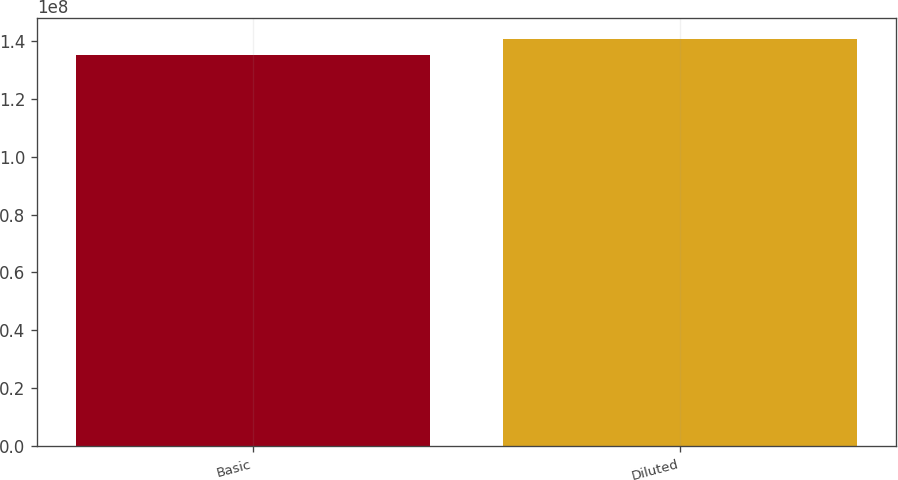<chart> <loc_0><loc_0><loc_500><loc_500><bar_chart><fcel>Basic<fcel>Diluted<nl><fcel>1.35305e+08<fcel>1.40743e+08<nl></chart> 